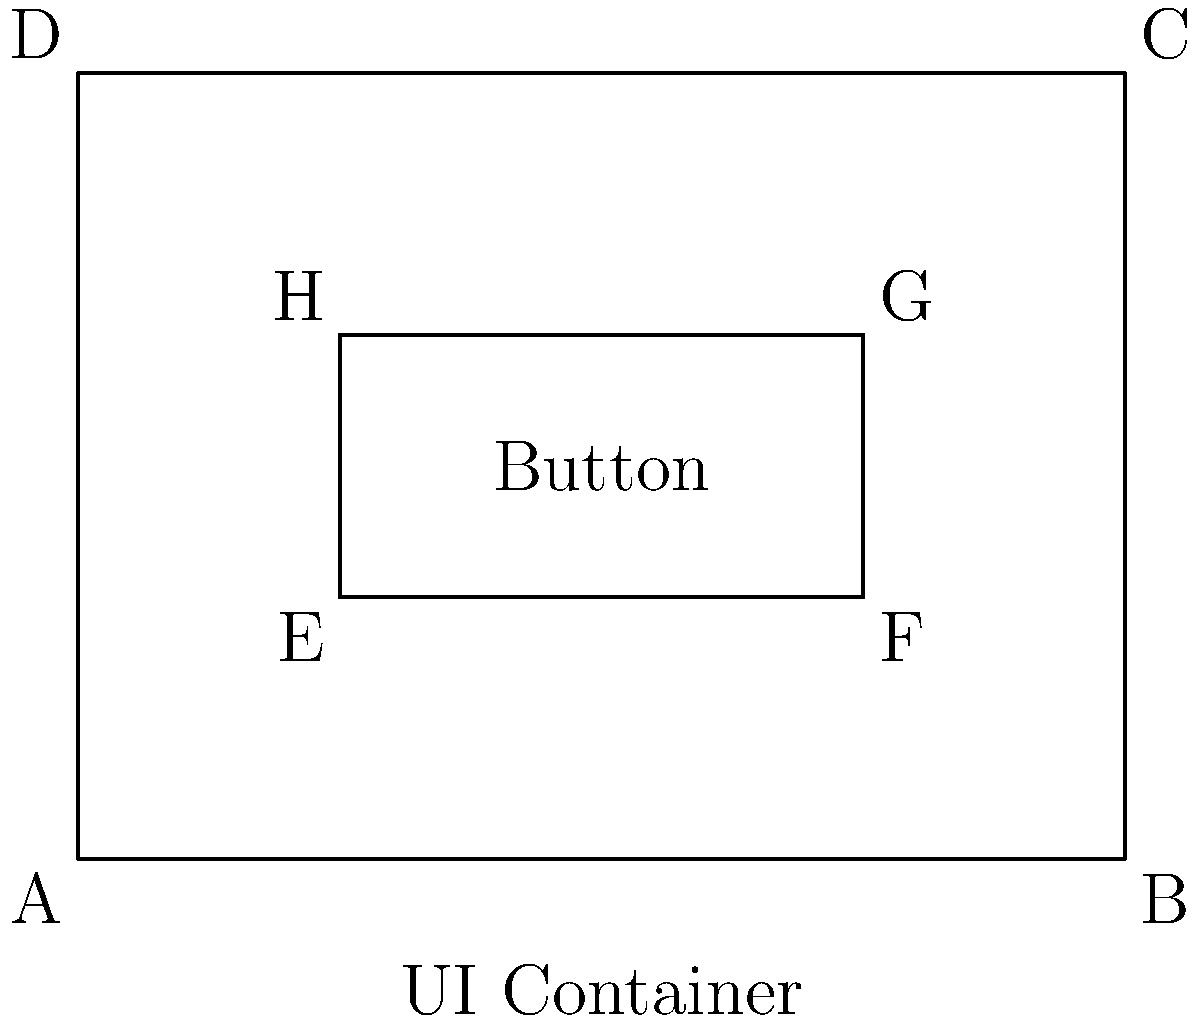In a user interface design layout, a rectangular button is placed within a larger rectangular container. The button's width is half the container's width, and its height is one-third of the container's height. If the container has a width of 400 pixels and a height of 300 pixels, prove that triangles AEH and BCF are congruent, where A, B, C, and D are the corners of the container, and E, F, G, and H are the corners of the button. To prove that triangles AEH and BCF are congruent, we'll use the Side-Angle-Side (SAS) congruence criterion. Let's follow these steps:

1. Establish the dimensions:
   - Container: 400px wide, 300px high
   - Button: 200px wide (half of 400px), 100px high (one-third of 300px)

2. Analyze triangle AEH:
   - AE = 100px (distance from left edge of container to left edge of button)
   - EH = 100px (height of button)
   - Angle AEH = 90° (right angle in rectangle)

3. Analyze triangle BCF:
   - BC = 300px (height of container)
   - CF = 100px (distance from right edge of container to right edge of button)
   - Angle BCF = 90° (right angle in rectangle)

4. Compare the triangles:
   - AE = CF (both 100px)
   - EH = BC (both 100px)
   - Angle AEH = Angle BCF (both 90°)

5. Apply SAS congruence criterion:
   Since two sides and the included angle are equal in both triangles, they are congruent by the SAS criterion.

Therefore, triangles AEH and BCF are congruent.
Answer: Triangles AEH and BCF are congruent by SAS criterion. 